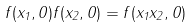<formula> <loc_0><loc_0><loc_500><loc_500>f ( x _ { 1 } , 0 ) f ( x _ { 2 } , 0 ) = f ( x _ { 1 } x _ { 2 } , 0 )</formula> 